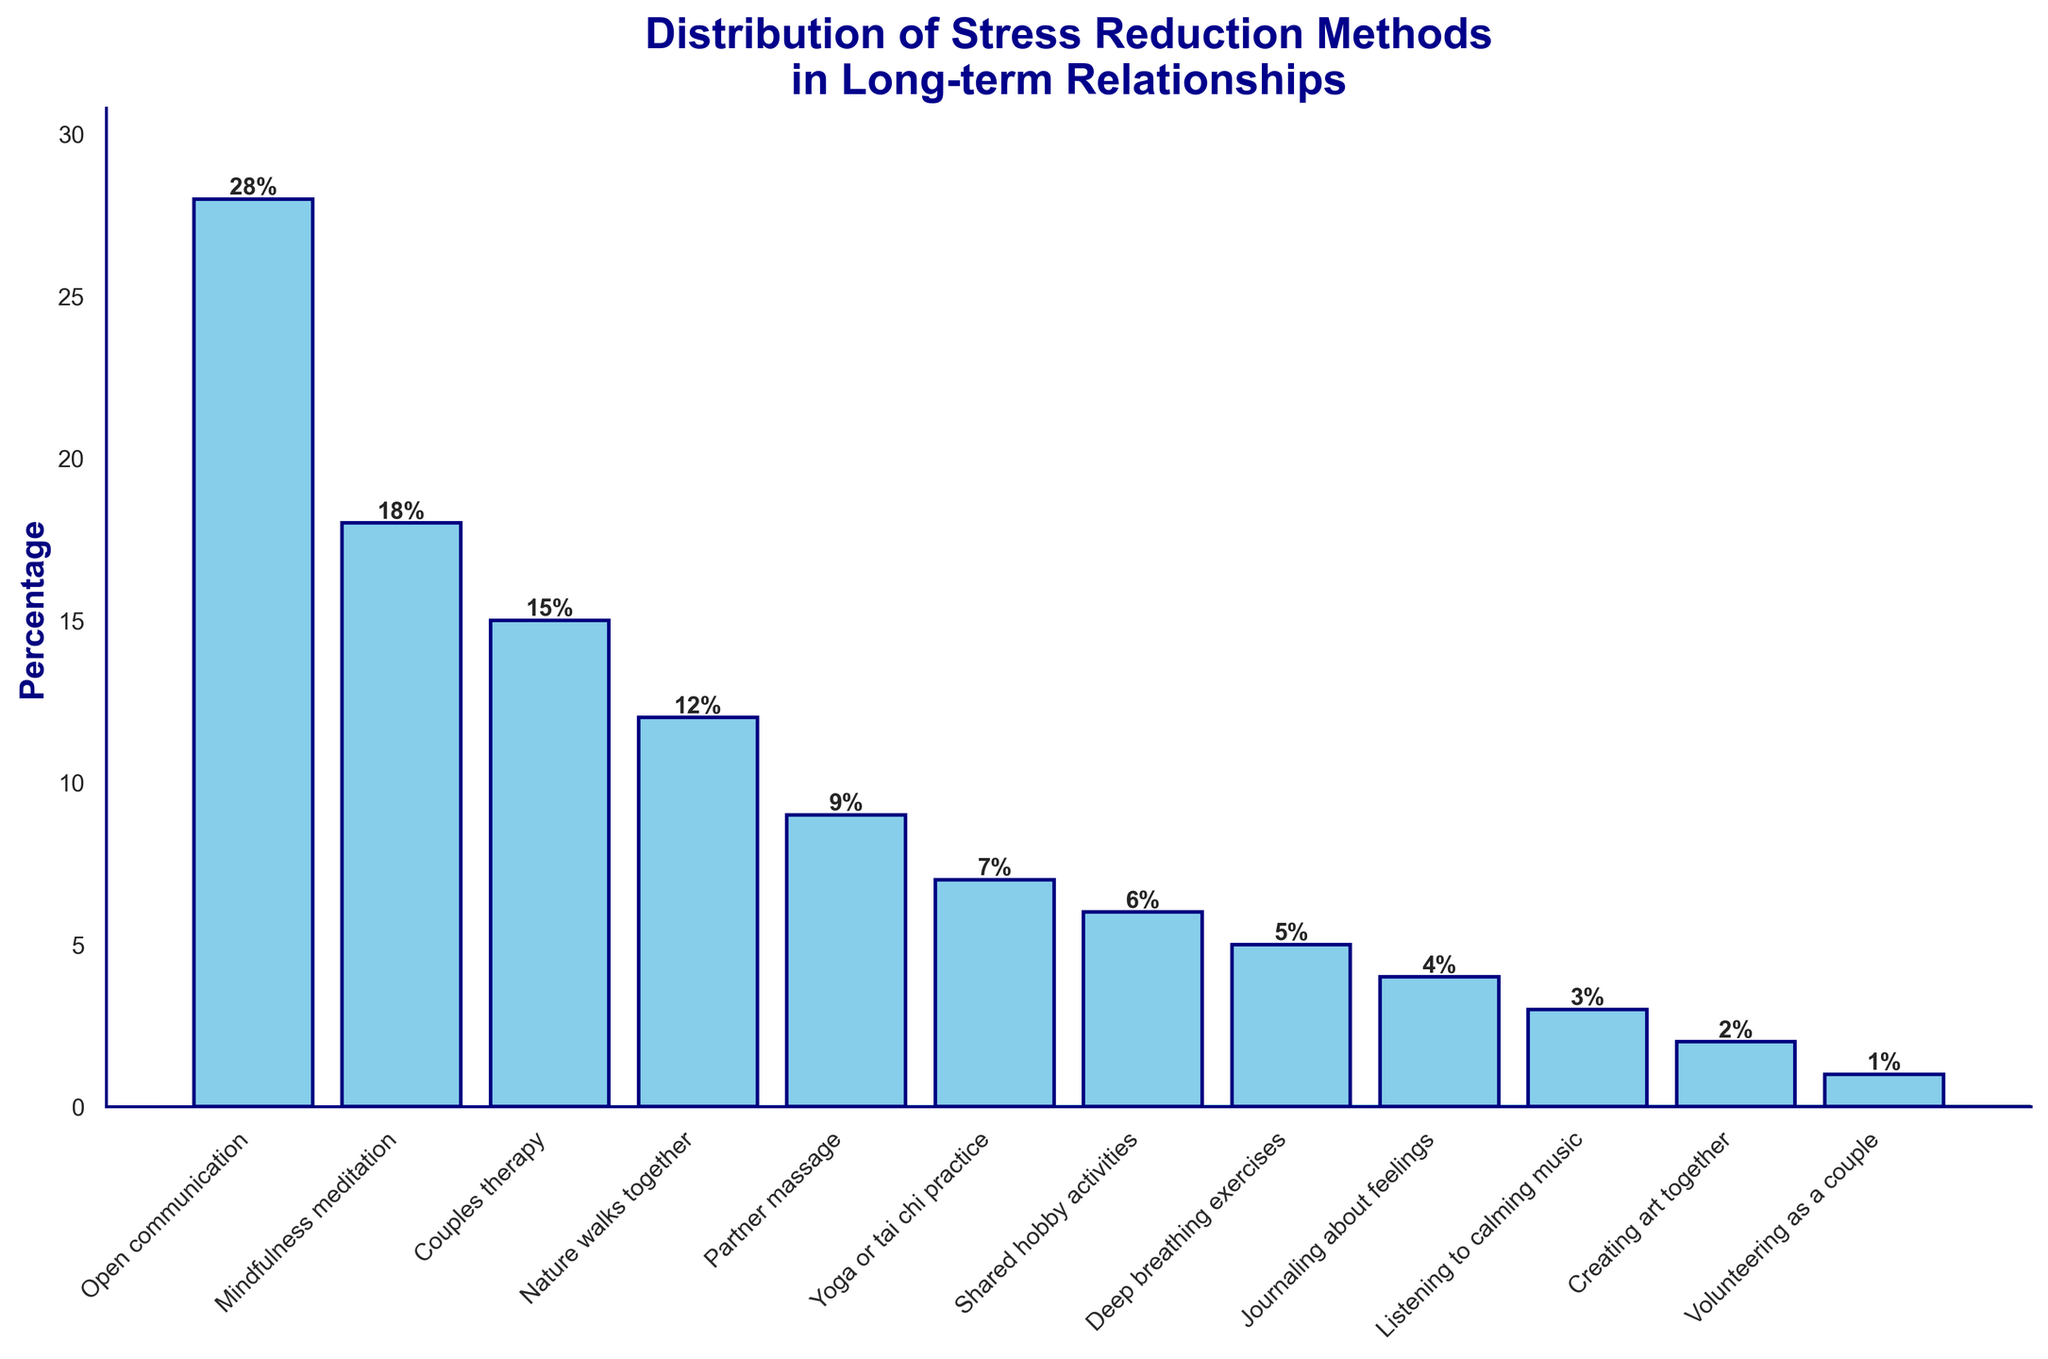what percentage of individuals prefer nature walks together? Look at the bar labeled "Nature walks together" and read the number at the top of the bar.
Answer: 12% Which method is preferred by the highest percentage of individuals? Identify the tallest bar on the chart.
Answer: Open communication What's the total percentage of individuals who prefer mindfulness meditation or couples therapy? Add the percentages for "Mindfulness meditation" and "Couples therapy". 18% (Mindfulness meditation) + 15% (Couples therapy) = 33%.
Answer: 33% Is partner massage preferred less than yoga or tai chi? Compare the height of the bars for "Partner massage" and "Yoga or tai chi practice".
Answer: No Which methods have a higher percentage preference than journaling about feelings? Identify all bars with a height greater than the bar for "Journaling about feelings".
Answer: Open communication, Mindfulness meditation, Couples therapy, Nature walks together, Partner massage, Yoga or tai chi practice, Shared hobby activities, Deep breathing exercises What is the sum percentage for the three least preferred methods? Add the percentages for the three smallest bars. 3% (Listening to calming music) + 2% (Creating art together) + 1% (Volunteering as a couple) = 6%.
Answer: 6% Compare the preference percentage of shared hobby activities with deep breathing exercises. Look at the bars for "Shared hobby activities" and "Deep breathing exercises" and compare their heights or labeled percentages.
Answer: Shared hobby activities has a higher percentage What is the median value of the percentages? Arrange the percentages in ascending order and find the middle value(s). The ordered percentages are 1, 2, 3, 4, 5, 6, 7, 9, 12, 15, 18, 28, so the median is the average of the 6th and 7th values: (7 + 9) / 2 = 8.
Answer: 8% How many methods are preferred by at least 10% of individuals? Count the number of bars that have heights of 10% or greater.
Answer: 4 Is the percentage for creating art together half of the percentage for partner massage? Compare the height of the bars for "Creating art together" (2%) and "Partner massage" (9%) and see if the former is half of the latter.
Answer: No 